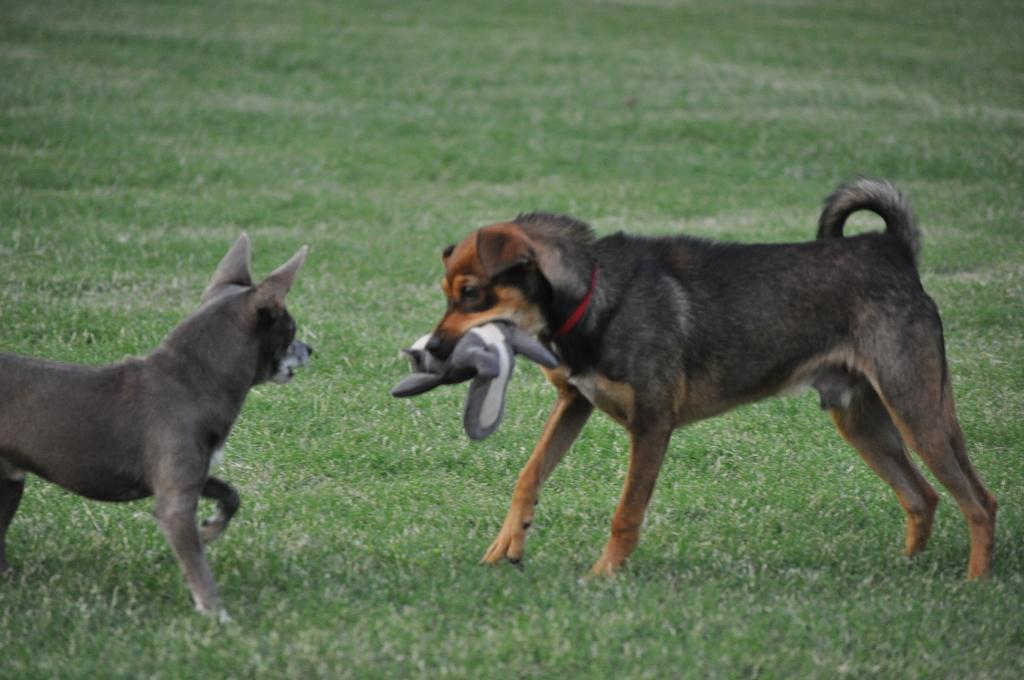What animals can be seen in the foreground of the image? There are two dogs in the foreground of the image. What is the surface the dogs are standing on? The dogs are on grass. Can you describe the object one of the dogs is holding in its mouth? One of the dogs is holding an object in its mouth, but the specific object is not clear from the image. What type of location might the image have been taken in? The image might have been taken in a park, given the presence of grass and the open space. What type of food is the turkey eating in the image? There is no turkey present in the image, so it is not possible to determine what, if any, food it might be eating. 